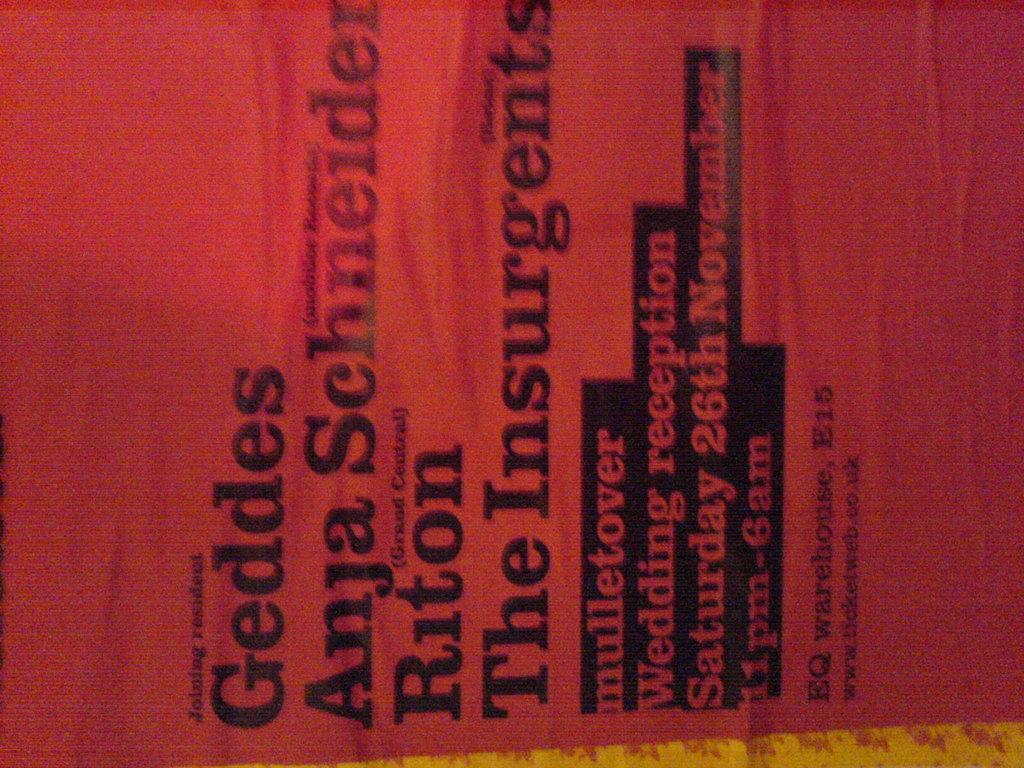What time is the wedding reception?
Keep it short and to the point. 11pm-6am. 